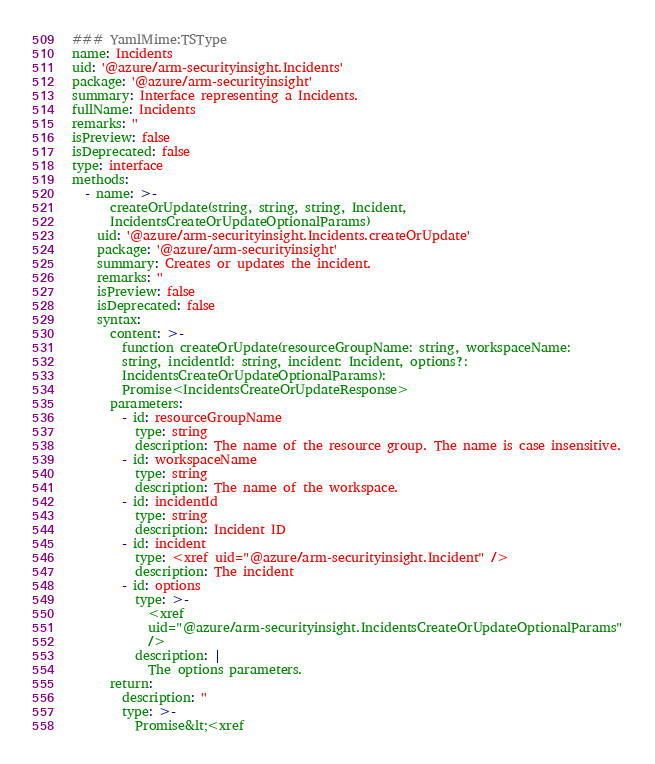Convert code to text. <code><loc_0><loc_0><loc_500><loc_500><_YAML_>### YamlMime:TSType
name: Incidents
uid: '@azure/arm-securityinsight.Incidents'
package: '@azure/arm-securityinsight'
summary: Interface representing a Incidents.
fullName: Incidents
remarks: ''
isPreview: false
isDeprecated: false
type: interface
methods:
  - name: >-
      createOrUpdate(string, string, string, Incident,
      IncidentsCreateOrUpdateOptionalParams)
    uid: '@azure/arm-securityinsight.Incidents.createOrUpdate'
    package: '@azure/arm-securityinsight'
    summary: Creates or updates the incident.
    remarks: ''
    isPreview: false
    isDeprecated: false
    syntax:
      content: >-
        function createOrUpdate(resourceGroupName: string, workspaceName:
        string, incidentId: string, incident: Incident, options?:
        IncidentsCreateOrUpdateOptionalParams):
        Promise<IncidentsCreateOrUpdateResponse>
      parameters:
        - id: resourceGroupName
          type: string
          description: The name of the resource group. The name is case insensitive.
        - id: workspaceName
          type: string
          description: The name of the workspace.
        - id: incidentId
          type: string
          description: Incident ID
        - id: incident
          type: <xref uid="@azure/arm-securityinsight.Incident" />
          description: The incident
        - id: options
          type: >-
            <xref
            uid="@azure/arm-securityinsight.IncidentsCreateOrUpdateOptionalParams"
            />
          description: |
            The options parameters.
      return:
        description: ''
        type: >-
          Promise&lt;<xref</code> 